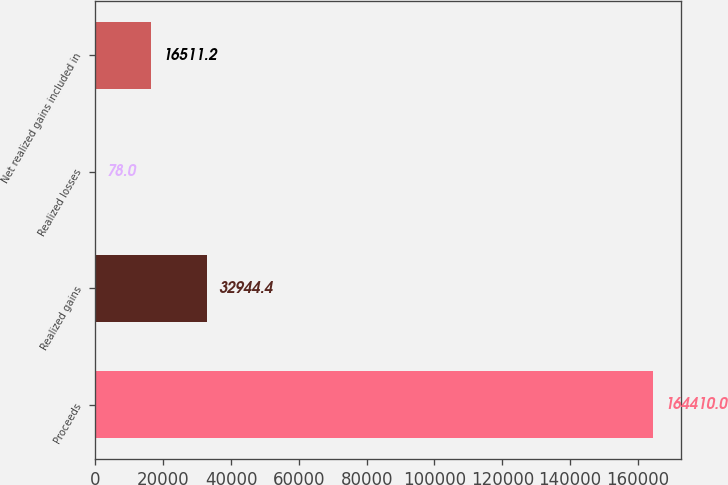Convert chart. <chart><loc_0><loc_0><loc_500><loc_500><bar_chart><fcel>Proceeds<fcel>Realized gains<fcel>Realized losses<fcel>Net realized gains included in<nl><fcel>164410<fcel>32944.4<fcel>78<fcel>16511.2<nl></chart> 